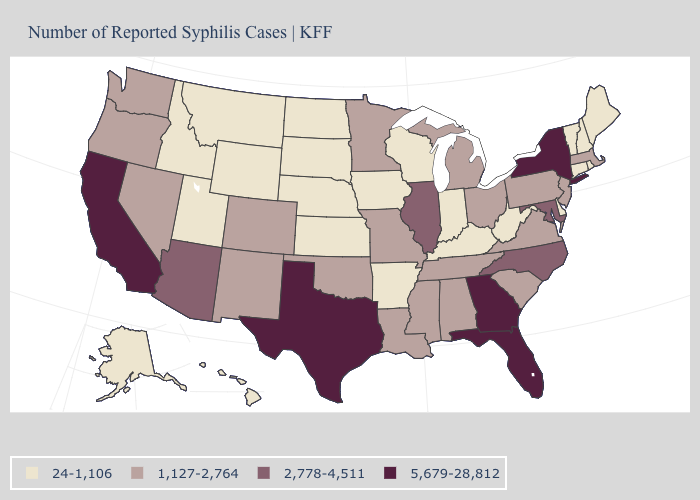Name the states that have a value in the range 24-1,106?
Write a very short answer. Alaska, Arkansas, Connecticut, Delaware, Hawaii, Idaho, Indiana, Iowa, Kansas, Kentucky, Maine, Montana, Nebraska, New Hampshire, North Dakota, Rhode Island, South Dakota, Utah, Vermont, West Virginia, Wisconsin, Wyoming. Name the states that have a value in the range 24-1,106?
Be succinct. Alaska, Arkansas, Connecticut, Delaware, Hawaii, Idaho, Indiana, Iowa, Kansas, Kentucky, Maine, Montana, Nebraska, New Hampshire, North Dakota, Rhode Island, South Dakota, Utah, Vermont, West Virginia, Wisconsin, Wyoming. Name the states that have a value in the range 1,127-2,764?
Concise answer only. Alabama, Colorado, Louisiana, Massachusetts, Michigan, Minnesota, Mississippi, Missouri, Nevada, New Jersey, New Mexico, Ohio, Oklahoma, Oregon, Pennsylvania, South Carolina, Tennessee, Virginia, Washington. What is the value of Utah?
Short answer required. 24-1,106. Name the states that have a value in the range 5,679-28,812?
Short answer required. California, Florida, Georgia, New York, Texas. Among the states that border Texas , which have the highest value?
Answer briefly. Louisiana, New Mexico, Oklahoma. What is the highest value in states that border North Carolina?
Write a very short answer. 5,679-28,812. Does the first symbol in the legend represent the smallest category?
Short answer required. Yes. Which states have the lowest value in the South?
Concise answer only. Arkansas, Delaware, Kentucky, West Virginia. Does Pennsylvania have the lowest value in the USA?
Write a very short answer. No. What is the value of Nevada?
Quick response, please. 1,127-2,764. How many symbols are there in the legend?
Answer briefly. 4. What is the value of Hawaii?
Short answer required. 24-1,106. How many symbols are there in the legend?
Write a very short answer. 4. What is the value of Kentucky?
Keep it brief. 24-1,106. 